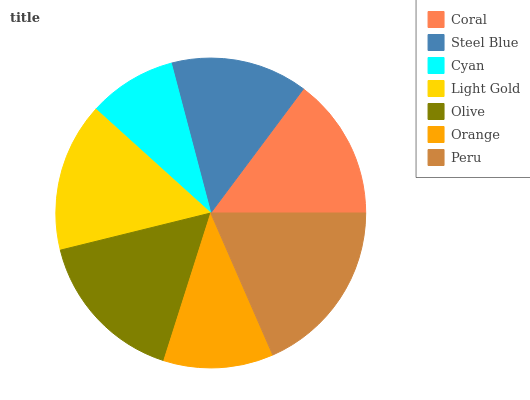Is Cyan the minimum?
Answer yes or no. Yes. Is Peru the maximum?
Answer yes or no. Yes. Is Steel Blue the minimum?
Answer yes or no. No. Is Steel Blue the maximum?
Answer yes or no. No. Is Coral greater than Steel Blue?
Answer yes or no. Yes. Is Steel Blue less than Coral?
Answer yes or no. Yes. Is Steel Blue greater than Coral?
Answer yes or no. No. Is Coral less than Steel Blue?
Answer yes or no. No. Is Coral the high median?
Answer yes or no. Yes. Is Coral the low median?
Answer yes or no. Yes. Is Steel Blue the high median?
Answer yes or no. No. Is Peru the low median?
Answer yes or no. No. 